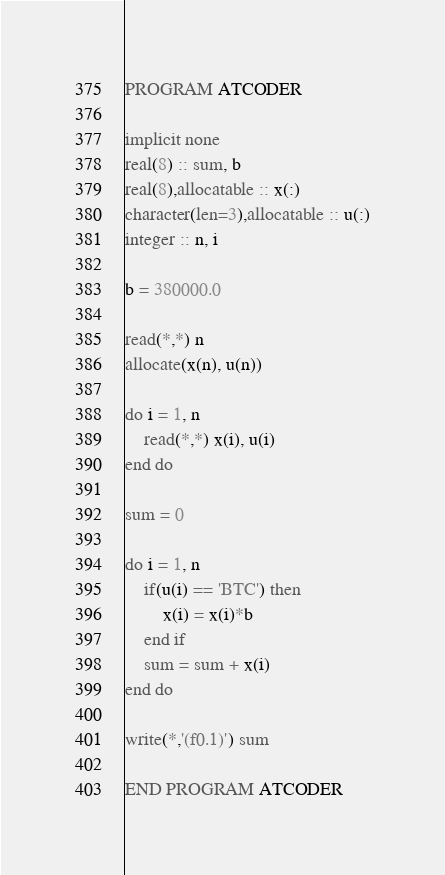Convert code to text. <code><loc_0><loc_0><loc_500><loc_500><_FORTRAN_>PROGRAM ATCODER

implicit none
real(8) :: sum, b
real(8),allocatable :: x(:)
character(len=3),allocatable :: u(:)
integer :: n, i

b = 380000.0

read(*,*) n
allocate(x(n), u(n))

do i = 1, n
	read(*,*) x(i), u(i)
end do

sum = 0

do i = 1, n
	if(u(i) == 'BTC') then
    	x(i) = x(i)*b
    end if
    sum = sum + x(i)
end do

write(*,'(f0.1)') sum

END PROGRAM ATCODER</code> 